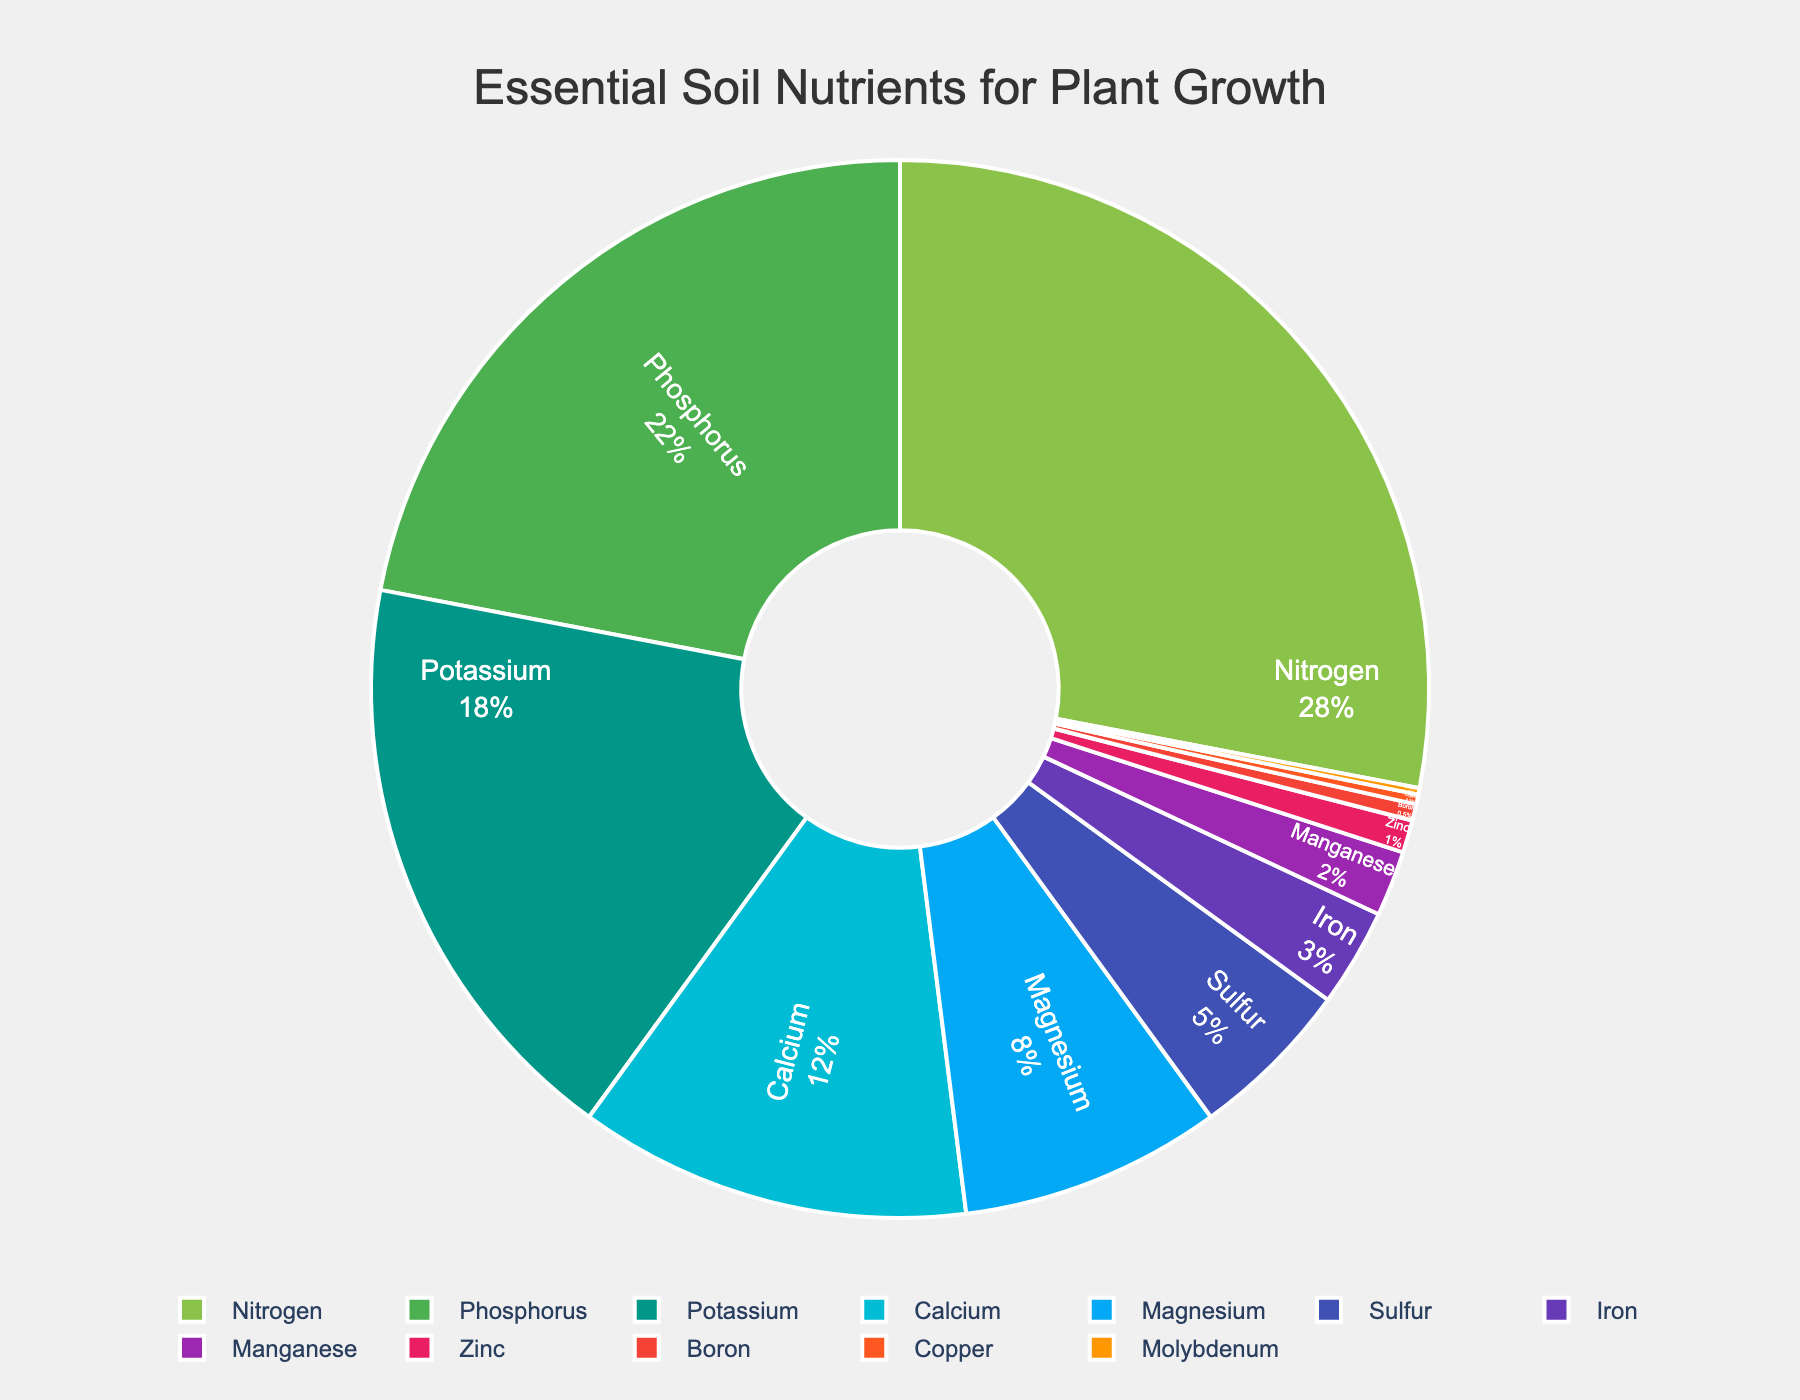what's the combined percentage of Nitrogen and Phosphorus? Add the percentages of Nitrogen and Phosphorus given in the figure. Nitrogen is 28% and Phosphorus is 22%. Therefore, 28% + 22% equals 50%.
Answer: 50% which nutrient is present in the lowest percentage? Look at the labels and percentages in the figure. The nutrient with the smallest segment is Molybdenum at 0.2%.
Answer: Molybdenum How does the percentage of Nitrogen compare to Potassium? Look at the percentages of Nitrogen and Potassium in the figure. Nitrogen is 28% while Potassium is 18%. Therefore, Nitrogen is 10 percentage points higher than Potassium.
Answer: Nitrogen is higher which nutrients have a percentage less than Sulfur? Identify Sulfur's percentage in the figure (5%) and list the nutrients with smaller percentages: Iron (3%), Manganese (2%), Zinc (1%), Boron (0.5%), Copper (0.3%), and Molybdenum (0.2%).
Answer: Iron, Manganese, Zinc, Boron, Copper, Molybdenum what is the total percentage of nutrients with a percentage greater than 10%? Find and sum the percentages of nutrients greater than 10%: Nitrogen (28%), Phosphorus (22%), Potassium (18%), and Calcium (12%). The total is 28% + 22% + 18% + 12% = 80%.
Answer: 80% which three segments are the smallest in the pie chart? Look at the figure to find the three smallest segments by percentage: Molybdenum (0.2%), Copper (0.3%), and Boron (0.5%).
Answer: Molybdenum, Copper, Boron what is the average percentage of Sulfur, Magnesium, and Calcium? Find the average of Sulfur, Magnesium, and Calcium percentages in the figure. Sum them up: 5% (Sulfur) + 8% (Magnesium) + 12% (Calcium) = 25%. The average is 25% / 3 = 8.33%.
Answer: 8.33% which nutrient is represented by the greenest segment in the pie chart? Observe the shades of green in the pie chart and identify the nutrient associated with the greenest (lightest green) segment, which belongs to Nitrogen.
Answer: Nitrogen 